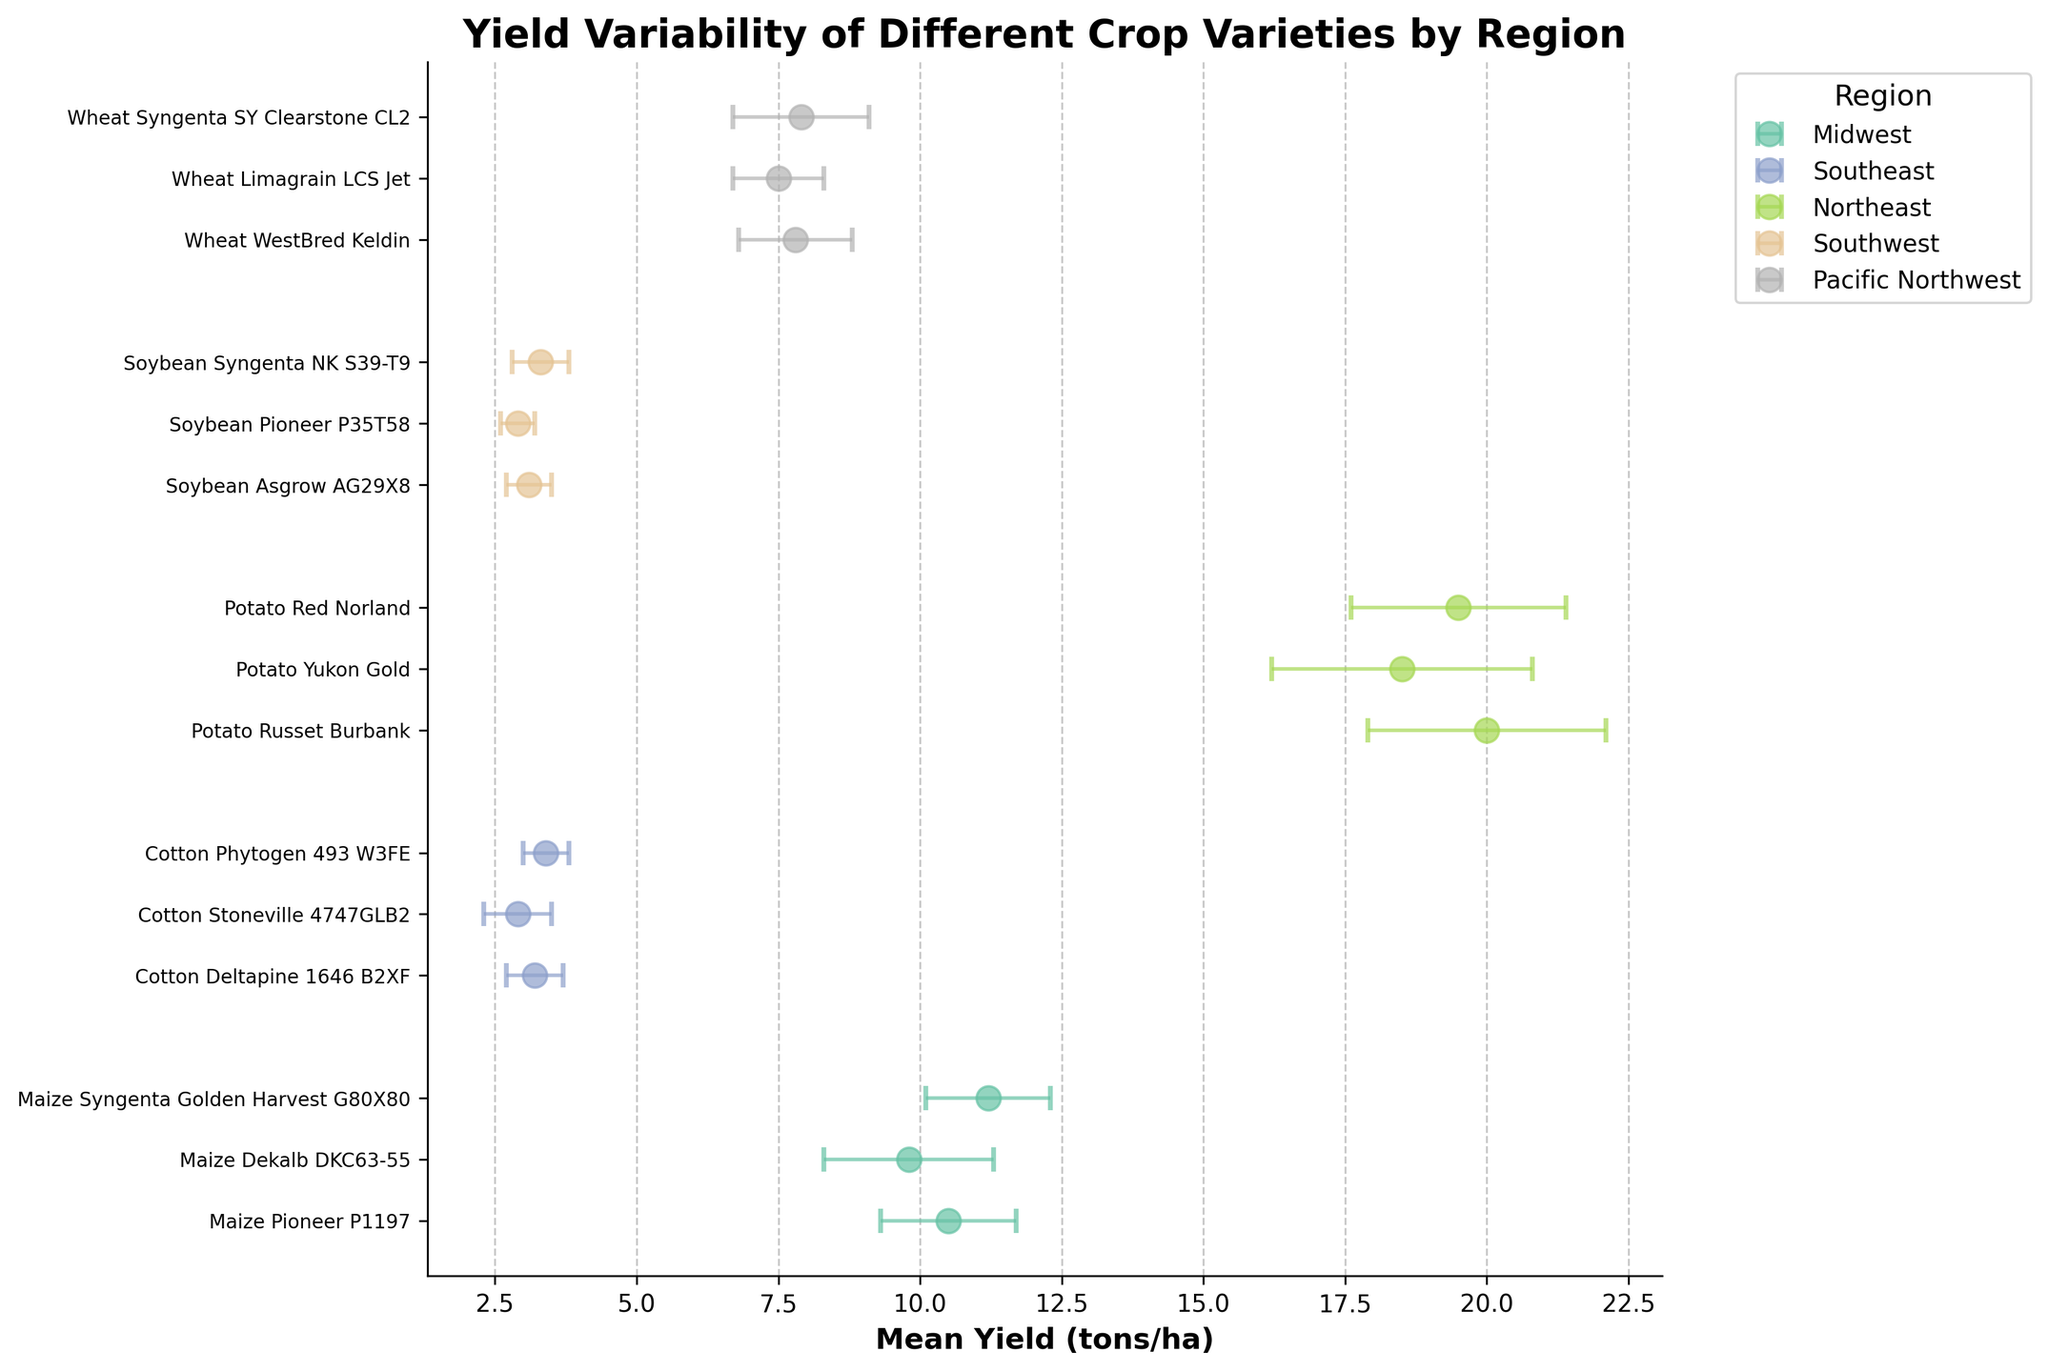What is the title of the figure? The title is displayed at the top of the chart and usually in a larger, bold font. In this figure, it reads 'Yield Variability of Different Crop Varieties by Region'.
Answer: Yield Variability of Different Crop Varieties by Region Which region has the highest mean yield for their crop variety? Comparing the mean yields of crop varieties across different regions visually, the Northeast region with 'Potato Russet Burbank' has the highest mean yield of 20.0 tons/ha.
Answer: Northeast What is the standard deviation for 'Maize Syngenta Golden Harvest G80X80'? For 'Maize Syngenta Golden Harvest G80X80' which is in the Midwest region, the error bars indicate the standard deviation. It is marked as 1.1 tons/ha in the figure.
Answer: 1.1 tons/ha Which crop variety has the lowest mean yield? Among all crop varieties, 'Cotton Stoneville 4747GLB2' in the Southeast region shows the lowest mean yield of 2.9 tons/ha.
Answer: Cotton Stoneville 4747GLB2 How many crop varieties are represented for the Southwest region? By counting the labeled data points for the Southwest region, there are three crop varieties: 'Soybean Asgrow AG29X8', 'Soybean Pioneer P35T58', and 'Soybean Syngenta NK S39-T9'.
Answer: Three What is the mean yield range of crop varieties in the Pacific Northwest region? The mean yields for crop varieties in the Pacific Northwest region are between 7.5 and 7.9 tons/ha. The smallest yield is for 'Wheat Limagrain LCS Jet', and the highest is for 'Wheat Syngenta SY Clearstone CL2'.
Answer: 7.5 to 7.9 tons/ha Which crop variety has the highest variation in yield as indicated by the error bars? The crop variety with the highest standard deviation, indicating the highest variation, is 'Potato Yukon Gold' in the Northeast region with a standard deviation of 2.3 tons/ha.
Answer: Potato Yukon Gold Are there any regions where all crop varieties have a standard deviation lower than 1 ton/ha? By examining the error bars, Southeast (Cotton) and Southwest (Soybean) regions each have all their crop varieties with a standard deviation below 1 ton/ha.
Answer: Yes, Southeast and Southwest Comparing 'Maize Pioneer P1197' and 'Maize Dekalb DKC63-55' in the Midwest region, which has a greater mean yield and by how much? 'Maize Pioneer P1197' has a greater mean yield of 10.5 tons/ha, while 'Maize Dekalb DKC63-55' has a mean yield of 9.8 tons/ha. The difference in their mean yields is 10.5 - 9.8 = 0.7 tons/ha.
Answer: Maize Pioneer P1197 by 0.7 tons/ha 